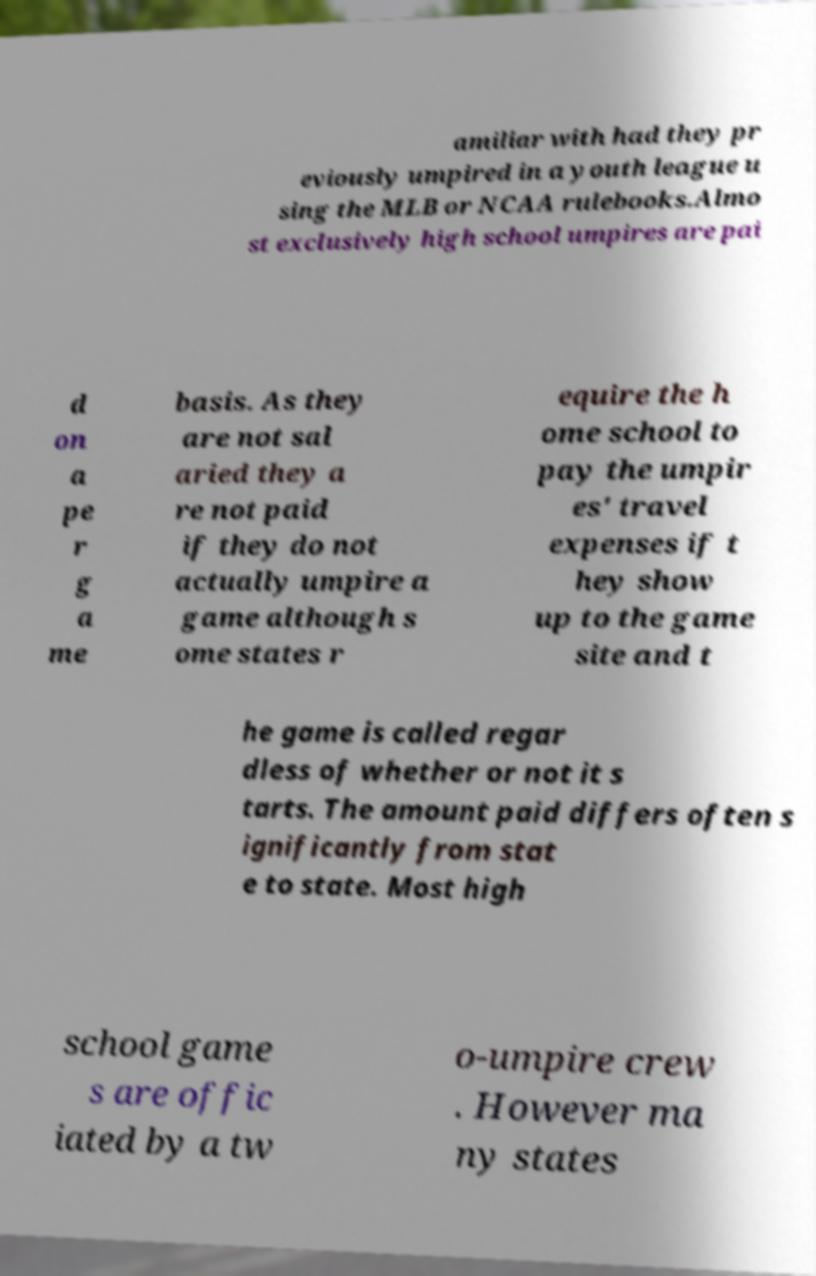For documentation purposes, I need the text within this image transcribed. Could you provide that? amiliar with had they pr eviously umpired in a youth league u sing the MLB or NCAA rulebooks.Almo st exclusively high school umpires are pai d on a pe r g a me basis. As they are not sal aried they a re not paid if they do not actually umpire a game although s ome states r equire the h ome school to pay the umpir es' travel expenses if t hey show up to the game site and t he game is called regar dless of whether or not it s tarts. The amount paid differs often s ignificantly from stat e to state. Most high school game s are offic iated by a tw o-umpire crew . However ma ny states 